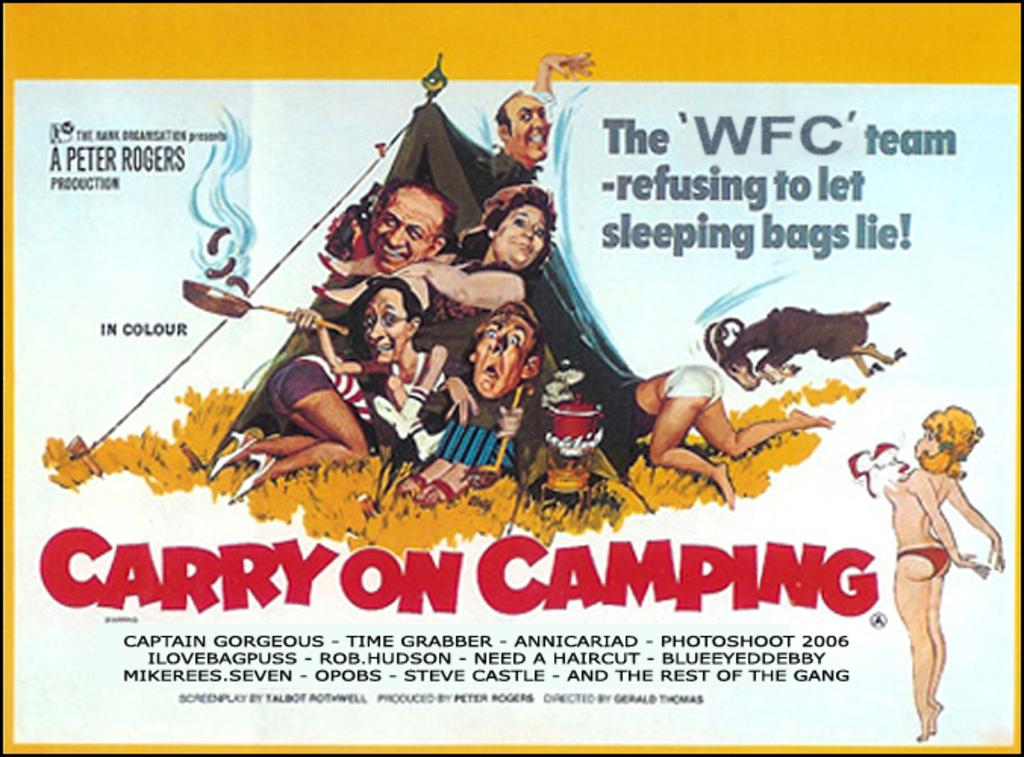What is present on the poster in the image? There is a poster in the image that contains images of people, animals, and text. Can you describe the content of the poster in more detail? The poster contains images of people and animals, as well as text. What type of snail can be seen crawling on the poster in the image? There is no snail present on the poster in the image. 